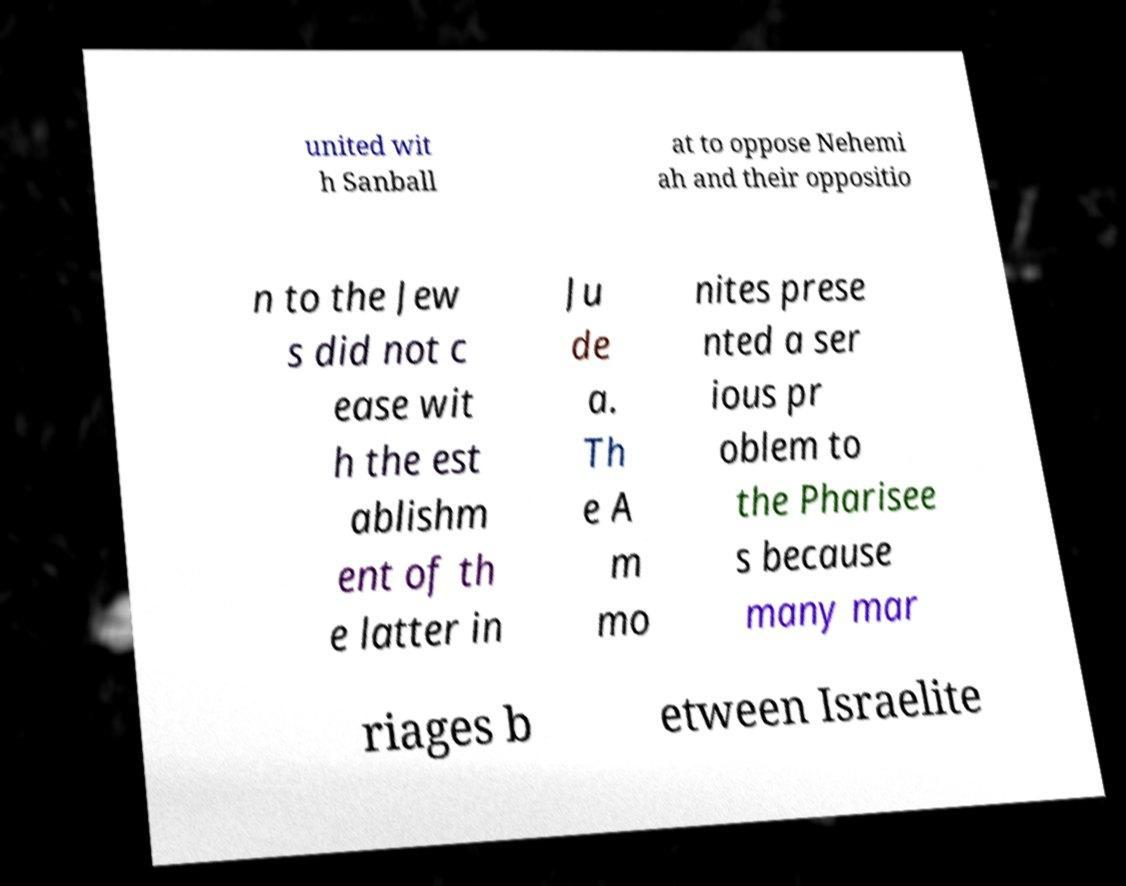Please read and relay the text visible in this image. What does it say? united wit h Sanball at to oppose Nehemi ah and their oppositio n to the Jew s did not c ease wit h the est ablishm ent of th e latter in Ju de a. Th e A m mo nites prese nted a ser ious pr oblem to the Pharisee s because many mar riages b etween Israelite 